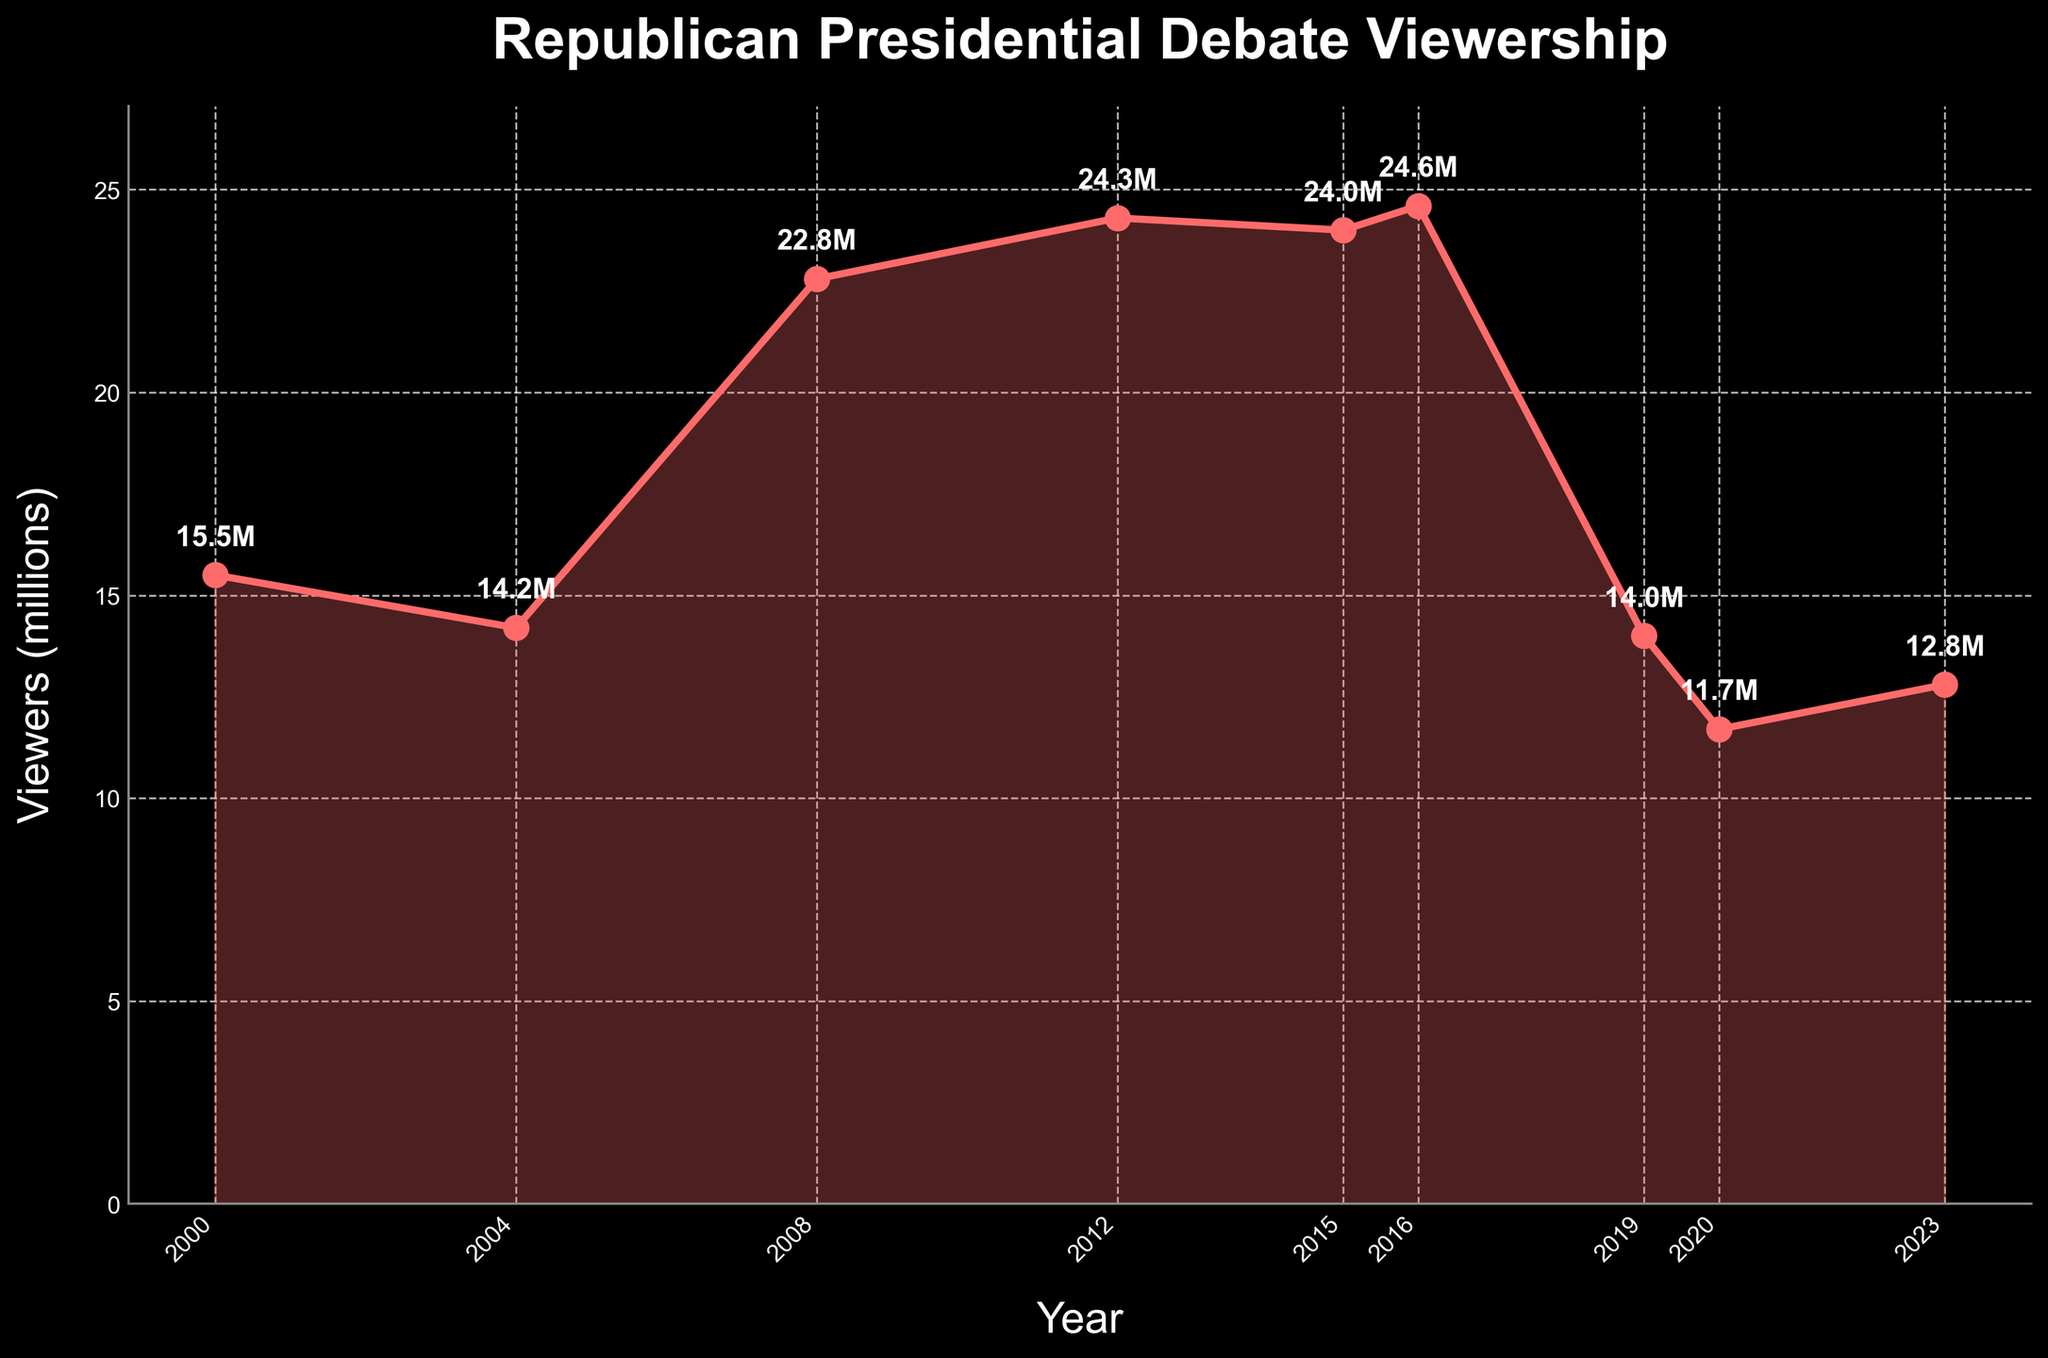How did the viewership change between the Republican presidential debates in 2000 and 2004? To find the change in viewership, subtract the 2004 viewership from the 2000 viewership. The viewership in 2000 was 15.5 million, and in 2004 it was 14.2 million. Therefore, the change is 15.5 - 14.2 = 1.3 million.
Answer: 1.3 million decrease Which year had the highest viewership, and what was the number of viewers? By examining the peak of the line on the plot, we can identify that 2016 had the highest viewership. The number next to the highest point on the plot shows it as 24.6 million viewers.
Answer: 2016 with 24.6 million viewers What is the average viewership across all the given years? Add up all the viewership numbers and divide by the number of years. (15.5 + 14.2 + 22.8 + 24.3 + 24 + 24.6 + 14 + 11.7 + 12.8) / 9 = 163.9 / 9 = 18.2 million.
Answer: 18.2 million How did the viewership in 2016 compare to that in 2020? Check the plot to find the viewership for both years. In 2016, it was 24.6 million, and in 2020, it was 11.7 million. To compare, subtract the 2020 viewership from the 2016 viewership: 24.6 - 11.7 = 12.9 million more in 2016.
Answer: 12.9 million more in 2016 Between which consecutive years did the largest drop in viewership occur, and by how much? By examining the declines between each pair of consecutive years, the largest drop occurred between 2016 and 2019. The viewership dropped from 24.6 million in 2016 to 14 million in 2019, a difference of 24.6 - 14 = 10.6 million.
Answer: Between 2016 and 2019, by 10.6 million What is the trend in viewership from 2008 to 2016? Look at the plot points from 2008 to 2016. The viewership starts at 22.8 million in 2008, rises slightly to 24.3 million in 2012, and then peaks at 24.6 million in 2016. The trend shows an overall increase.
Answer: Increasing trend Which two consecutive years had the smallest change in viewership, and what was the change? Examine the differences between consecutive years. The smallest change occurred between 2012 and 2015 where the viewership went from 24.3 million to 24 million, only a decrease of 0.3 million.
Answer: Between 2012 and 2015, by 0.3 million Did the viewership in 2023 increase or decrease compared to 2019, and by how much? Check the plot points for 2019 and 2023. In 2019, the viewership was 14 million, and in 2023 it was 12.8 million. Subtract the 2023 viewership from the 2019 viewership: 14 - 12.8 = 1.2 million decrease.
Answer: Decrease by 1.2 million 